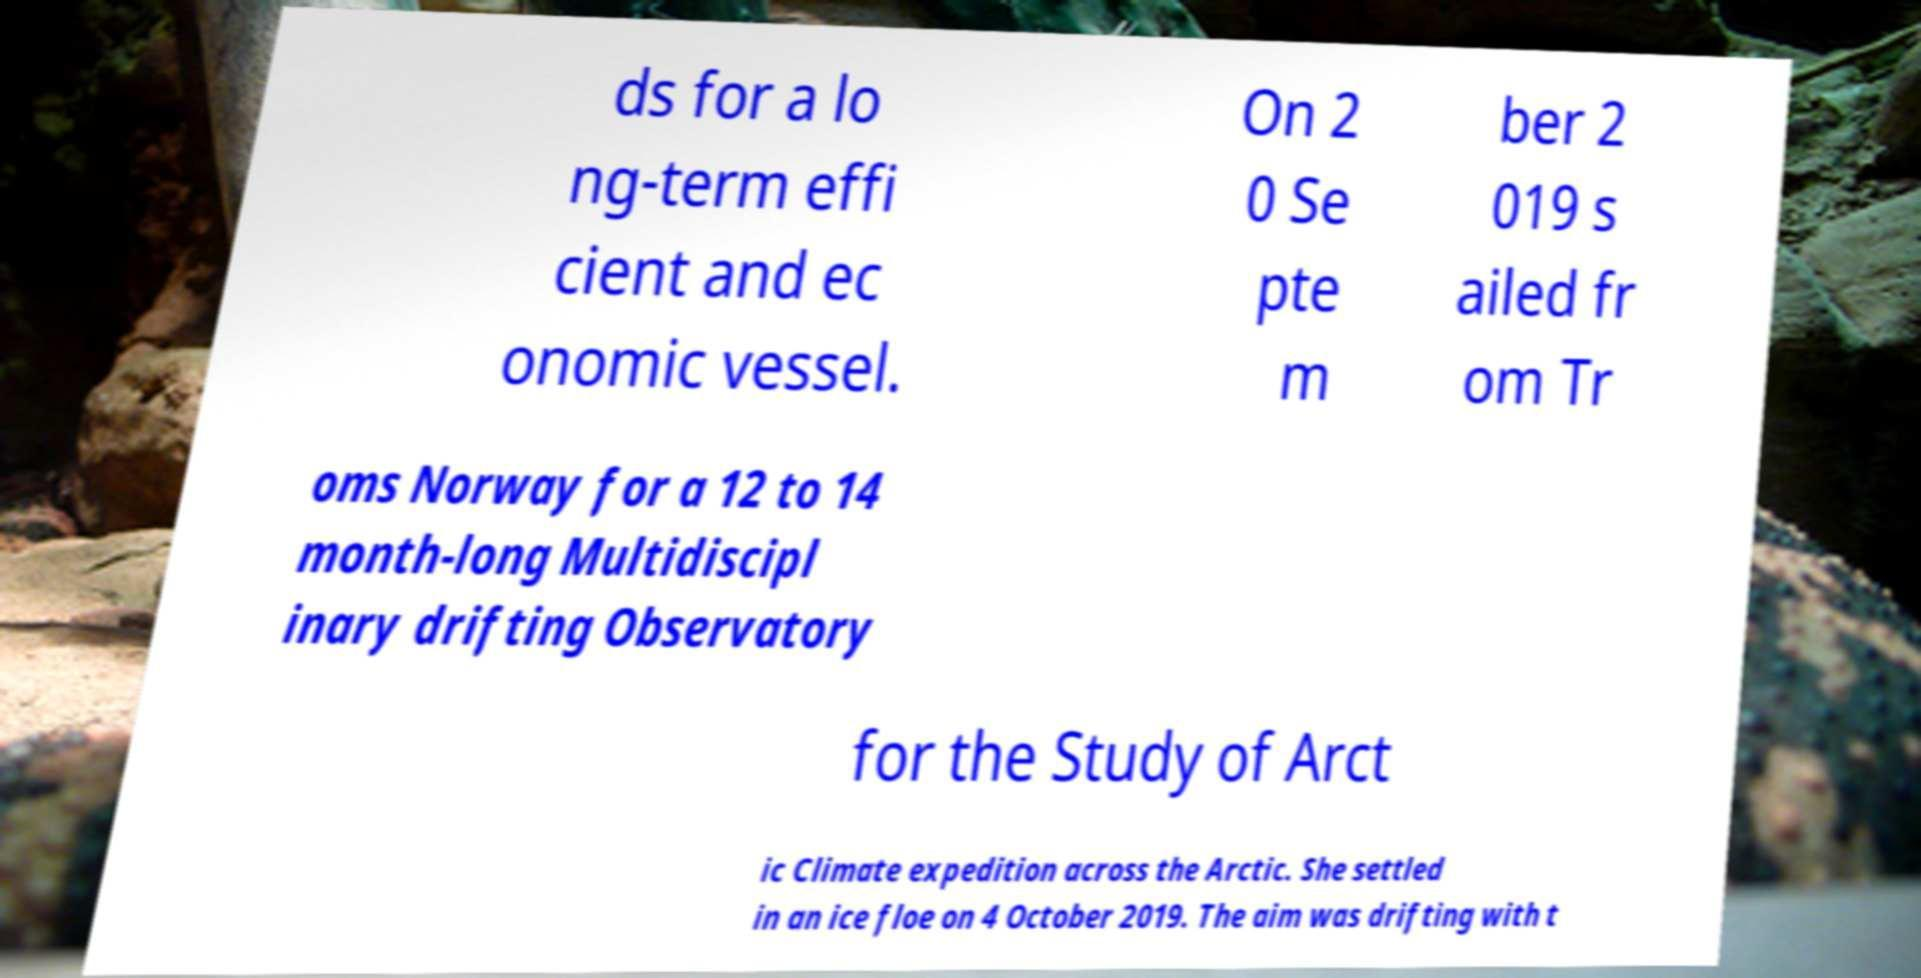Can you read and provide the text displayed in the image?This photo seems to have some interesting text. Can you extract and type it out for me? ds for a lo ng-term effi cient and ec onomic vessel. On 2 0 Se pte m ber 2 019 s ailed fr om Tr oms Norway for a 12 to 14 month-long Multidiscipl inary drifting Observatory for the Study of Arct ic Climate expedition across the Arctic. She settled in an ice floe on 4 October 2019. The aim was drifting with t 